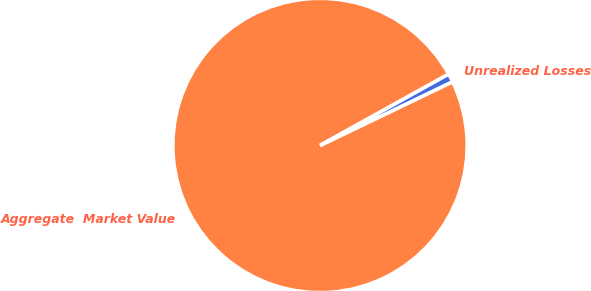Convert chart. <chart><loc_0><loc_0><loc_500><loc_500><pie_chart><fcel>Aggregate  Market Value<fcel>Unrealized Losses<nl><fcel>99.08%<fcel>0.92%<nl></chart> 